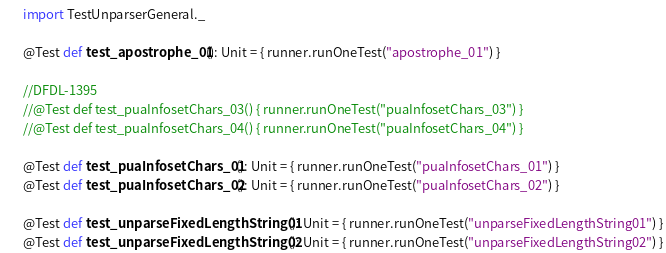<code> <loc_0><loc_0><loc_500><loc_500><_Scala_>
  import TestUnparserGeneral._

  @Test def test_apostrophe_01(): Unit = { runner.runOneTest("apostrophe_01") }

  //DFDL-1395
  //@Test def test_puaInfosetChars_03() { runner.runOneTest("puaInfosetChars_03") }
  //@Test def test_puaInfosetChars_04() { runner.runOneTest("puaInfosetChars_04") }

  @Test def test_puaInfosetChars_01(): Unit = { runner.runOneTest("puaInfosetChars_01") }
  @Test def test_puaInfosetChars_02(): Unit = { runner.runOneTest("puaInfosetChars_02") }

  @Test def test_unparseFixedLengthString01(): Unit = { runner.runOneTest("unparseFixedLengthString01") }
  @Test def test_unparseFixedLengthString02(): Unit = { runner.runOneTest("unparseFixedLengthString02") }</code> 